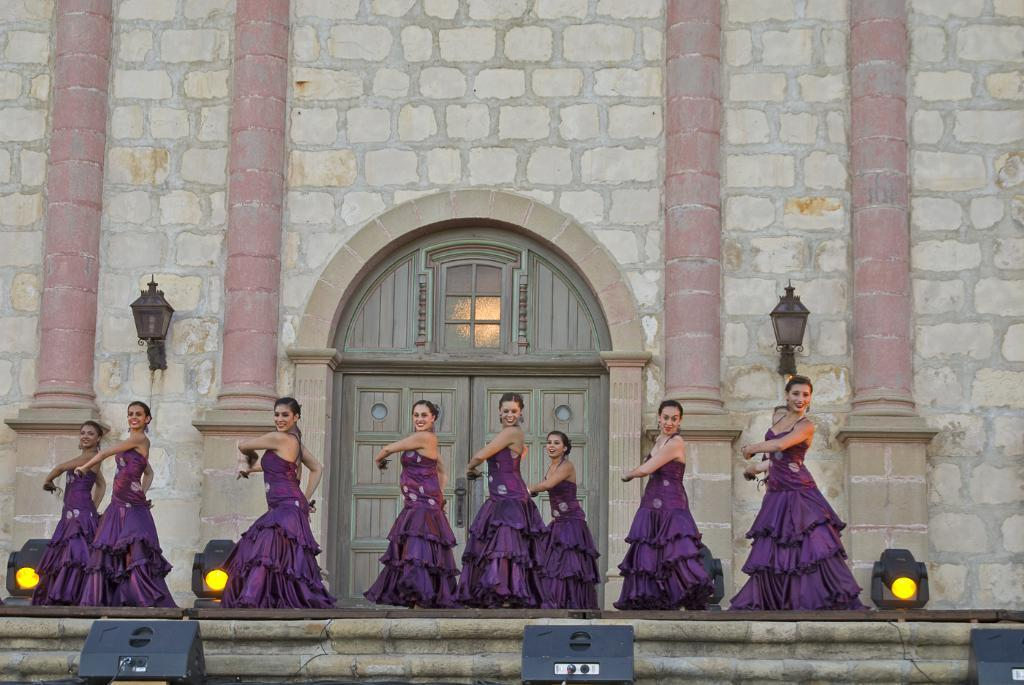What is the main subject of the image? There is a group of people in the image. What are the people wearing? The people are wearing purple color dresses. What can be seen in the background of the image? There are lights and a door visible in the background of the image. How is the door connected to the wall? The door is connected to a wall. Where is the light located in relation to the image? There is a light to the side of the image. What type of grain is being harvested by the people in the image? There is no grain or harvesting activity depicted in the image; it features a group of people wearing purple dresses. What kind of map is being used by the guide in the image? There is no guide or map present in the image; it only shows a group of people and a door connected to a wall. 